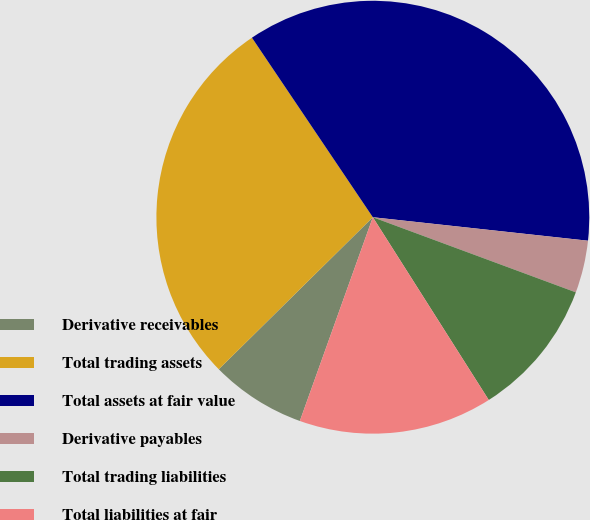Convert chart. <chart><loc_0><loc_0><loc_500><loc_500><pie_chart><fcel>Derivative receivables<fcel>Total trading assets<fcel>Total assets at fair value<fcel>Derivative payables<fcel>Total trading liabilities<fcel>Total liabilities at fair<nl><fcel>7.13%<fcel>27.96%<fcel>36.16%<fcel>3.91%<fcel>10.36%<fcel>14.47%<nl></chart> 